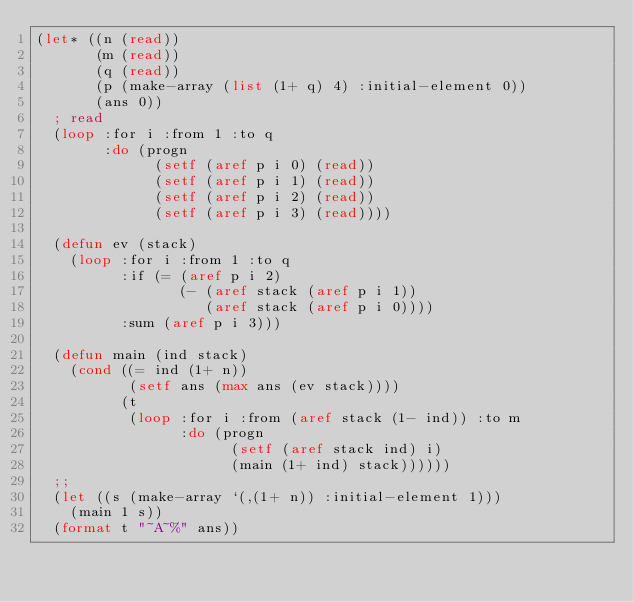Convert code to text. <code><loc_0><loc_0><loc_500><loc_500><_Lisp_>(let* ((n (read))
       (m (read))
       (q (read))
       (p (make-array (list (1+ q) 4) :initial-element 0))
       (ans 0))
  ; read
  (loop :for i :from 1 :to q
        :do (progn
              (setf (aref p i 0) (read))
              (setf (aref p i 1) (read))
              (setf (aref p i 2) (read))
              (setf (aref p i 3) (read))))
  
  (defun ev (stack)
    (loop :for i :from 1 :to q
          :if (= (aref p i 2)
                 (- (aref stack (aref p i 1))
                    (aref stack (aref p i 0))))
          :sum (aref p i 3)))

  (defun main (ind stack)
    (cond ((= ind (1+ n))
           (setf ans (max ans (ev stack))))
          (t
           (loop :for i :from (aref stack (1- ind)) :to m
                 :do (progn
                       (setf (aref stack ind) i)
                       (main (1+ ind) stack))))))
  ;;
  (let ((s (make-array `(,(1+ n)) :initial-element 1)))
    (main 1 s))
  (format t "~A~%" ans))
</code> 